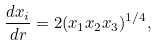<formula> <loc_0><loc_0><loc_500><loc_500>\frac { d x _ { i } } { d r } = 2 ( x _ { 1 } x _ { 2 } x _ { 3 } ) ^ { 1 / 4 } ,</formula> 